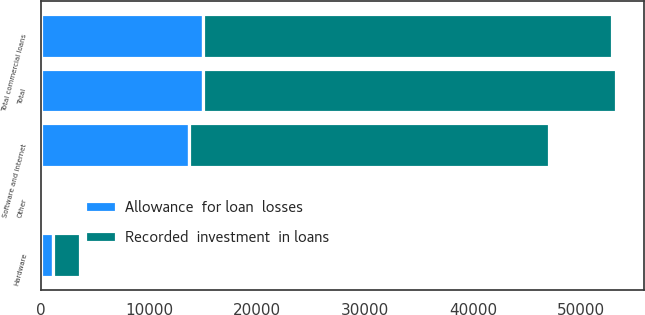<chart> <loc_0><loc_0><loc_500><loc_500><stacked_bar_chart><ecel><fcel>Software and internet<fcel>Hardware<fcel>Other<fcel>Total commercial loans<fcel>Total<nl><fcel>Allowance  for loan  losses<fcel>13695<fcel>1133<fcel>71<fcel>15020<fcel>15051<nl><fcel>Recorded  investment  in loans<fcel>33287<fcel>2521<fcel>233<fcel>37820<fcel>38137<nl></chart> 